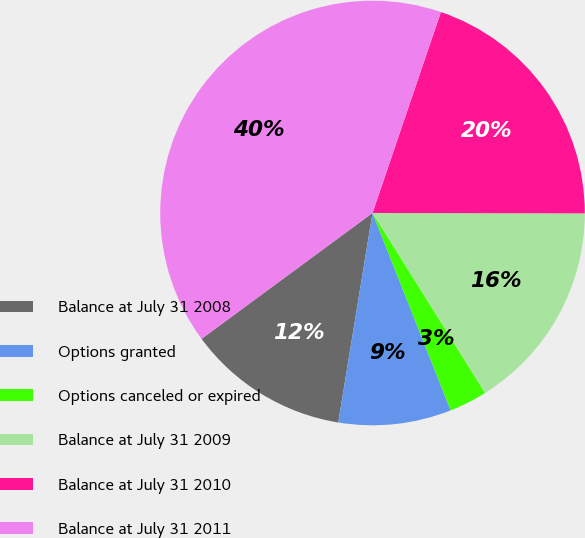Convert chart. <chart><loc_0><loc_0><loc_500><loc_500><pie_chart><fcel>Balance at July 31 2008<fcel>Options granted<fcel>Options canceled or expired<fcel>Balance at July 31 2009<fcel>Balance at July 31 2010<fcel>Balance at July 31 2011<nl><fcel>12.32%<fcel>8.58%<fcel>2.9%<fcel>16.07%<fcel>19.81%<fcel>40.32%<nl></chart> 